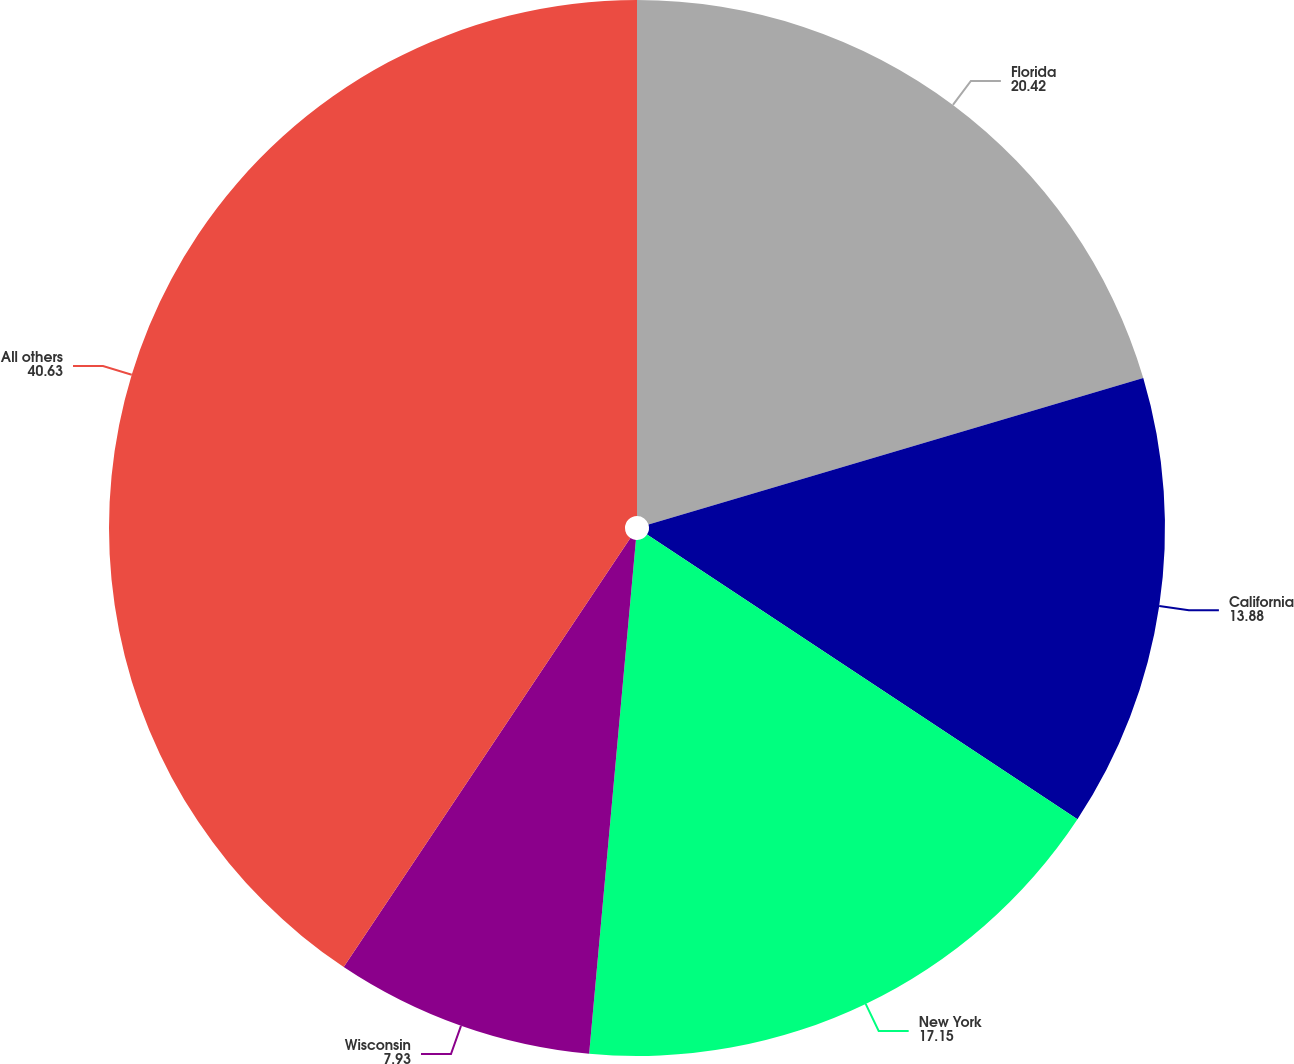Convert chart to OTSL. <chart><loc_0><loc_0><loc_500><loc_500><pie_chart><fcel>Florida<fcel>California<fcel>New York<fcel>Wisconsin<fcel>All others<nl><fcel>20.42%<fcel>13.88%<fcel>17.15%<fcel>7.93%<fcel>40.63%<nl></chart> 